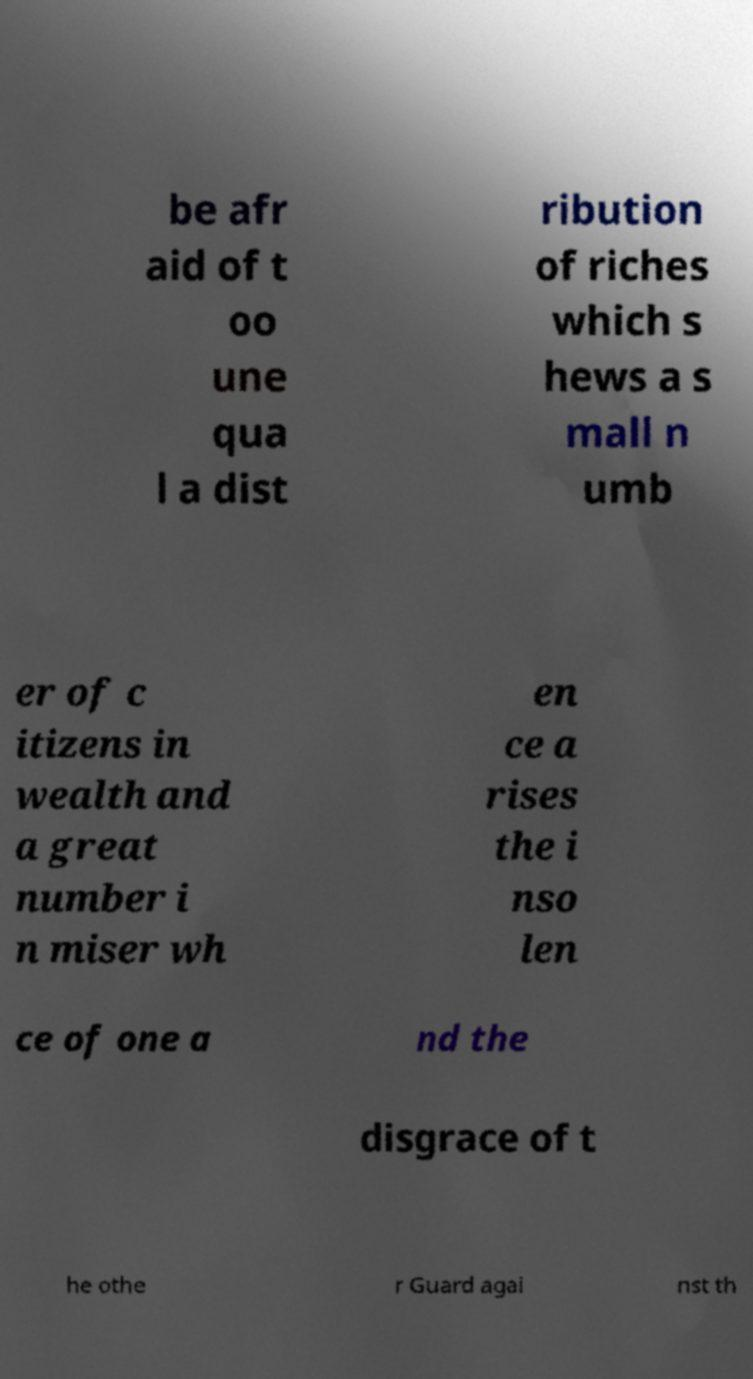Could you assist in decoding the text presented in this image and type it out clearly? be afr aid of t oo une qua l a dist ribution of riches which s hews a s mall n umb er of c itizens in wealth and a great number i n miser wh en ce a rises the i nso len ce of one a nd the disgrace of t he othe r Guard agai nst th 